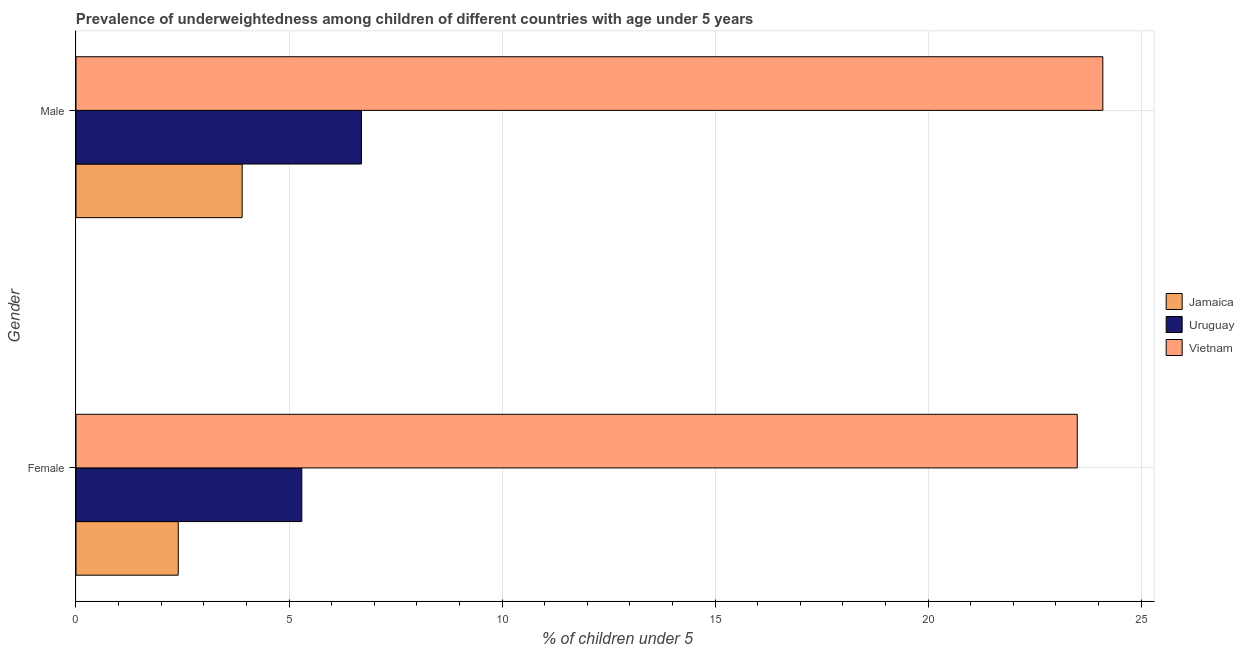How many different coloured bars are there?
Offer a terse response. 3. How many groups of bars are there?
Ensure brevity in your answer.  2. How many bars are there on the 2nd tick from the top?
Make the answer very short. 3. What is the percentage of underweighted male children in Vietnam?
Provide a succinct answer. 24.1. Across all countries, what is the maximum percentage of underweighted male children?
Make the answer very short. 24.1. Across all countries, what is the minimum percentage of underweighted male children?
Your answer should be compact. 3.9. In which country was the percentage of underweighted male children maximum?
Your response must be concise. Vietnam. In which country was the percentage of underweighted female children minimum?
Keep it short and to the point. Jamaica. What is the total percentage of underweighted female children in the graph?
Offer a very short reply. 31.2. What is the difference between the percentage of underweighted female children in Jamaica and that in Uruguay?
Your answer should be compact. -2.9. What is the difference between the percentage of underweighted male children in Jamaica and the percentage of underweighted female children in Uruguay?
Provide a short and direct response. -1.4. What is the average percentage of underweighted female children per country?
Offer a very short reply. 10.4. What is the difference between the percentage of underweighted female children and percentage of underweighted male children in Uruguay?
Provide a short and direct response. -1.4. In how many countries, is the percentage of underweighted male children greater than 3 %?
Make the answer very short. 3. What is the ratio of the percentage of underweighted male children in Uruguay to that in Vietnam?
Ensure brevity in your answer.  0.28. Is the percentage of underweighted female children in Jamaica less than that in Vietnam?
Provide a short and direct response. Yes. In how many countries, is the percentage of underweighted female children greater than the average percentage of underweighted female children taken over all countries?
Provide a succinct answer. 1. What does the 2nd bar from the top in Female represents?
Your answer should be very brief. Uruguay. What does the 2nd bar from the bottom in Male represents?
Provide a succinct answer. Uruguay. Are all the bars in the graph horizontal?
Provide a succinct answer. Yes. Are the values on the major ticks of X-axis written in scientific E-notation?
Offer a terse response. No. Does the graph contain grids?
Ensure brevity in your answer.  Yes. How many legend labels are there?
Make the answer very short. 3. What is the title of the graph?
Offer a very short reply. Prevalence of underweightedness among children of different countries with age under 5 years. What is the label or title of the X-axis?
Provide a short and direct response.  % of children under 5. What is the  % of children under 5 in Jamaica in Female?
Offer a terse response. 2.4. What is the  % of children under 5 of Uruguay in Female?
Your answer should be compact. 5.3. What is the  % of children under 5 of Jamaica in Male?
Make the answer very short. 3.9. What is the  % of children under 5 in Uruguay in Male?
Ensure brevity in your answer.  6.7. What is the  % of children under 5 in Vietnam in Male?
Provide a short and direct response. 24.1. Across all Gender, what is the maximum  % of children under 5 in Jamaica?
Your answer should be very brief. 3.9. Across all Gender, what is the maximum  % of children under 5 in Uruguay?
Ensure brevity in your answer.  6.7. Across all Gender, what is the maximum  % of children under 5 in Vietnam?
Offer a terse response. 24.1. Across all Gender, what is the minimum  % of children under 5 of Jamaica?
Offer a very short reply. 2.4. Across all Gender, what is the minimum  % of children under 5 of Uruguay?
Offer a terse response. 5.3. Across all Gender, what is the minimum  % of children under 5 in Vietnam?
Your answer should be very brief. 23.5. What is the total  % of children under 5 of Vietnam in the graph?
Offer a terse response. 47.6. What is the difference between the  % of children under 5 of Vietnam in Female and that in Male?
Provide a succinct answer. -0.6. What is the difference between the  % of children under 5 of Jamaica in Female and the  % of children under 5 of Vietnam in Male?
Provide a succinct answer. -21.7. What is the difference between the  % of children under 5 of Uruguay in Female and the  % of children under 5 of Vietnam in Male?
Ensure brevity in your answer.  -18.8. What is the average  % of children under 5 of Jamaica per Gender?
Provide a succinct answer. 3.15. What is the average  % of children under 5 of Uruguay per Gender?
Offer a terse response. 6. What is the average  % of children under 5 of Vietnam per Gender?
Offer a very short reply. 23.8. What is the difference between the  % of children under 5 in Jamaica and  % of children under 5 in Vietnam in Female?
Keep it short and to the point. -21.1. What is the difference between the  % of children under 5 in Uruguay and  % of children under 5 in Vietnam in Female?
Give a very brief answer. -18.2. What is the difference between the  % of children under 5 in Jamaica and  % of children under 5 in Vietnam in Male?
Your answer should be very brief. -20.2. What is the difference between the  % of children under 5 of Uruguay and  % of children under 5 of Vietnam in Male?
Give a very brief answer. -17.4. What is the ratio of the  % of children under 5 of Jamaica in Female to that in Male?
Your response must be concise. 0.62. What is the ratio of the  % of children under 5 in Uruguay in Female to that in Male?
Make the answer very short. 0.79. What is the ratio of the  % of children under 5 of Vietnam in Female to that in Male?
Provide a succinct answer. 0.98. What is the difference between the highest and the second highest  % of children under 5 of Jamaica?
Provide a short and direct response. 1.5. What is the difference between the highest and the second highest  % of children under 5 of Uruguay?
Offer a very short reply. 1.4. What is the difference between the highest and the lowest  % of children under 5 of Jamaica?
Offer a very short reply. 1.5. What is the difference between the highest and the lowest  % of children under 5 of Uruguay?
Provide a short and direct response. 1.4. What is the difference between the highest and the lowest  % of children under 5 of Vietnam?
Provide a succinct answer. 0.6. 